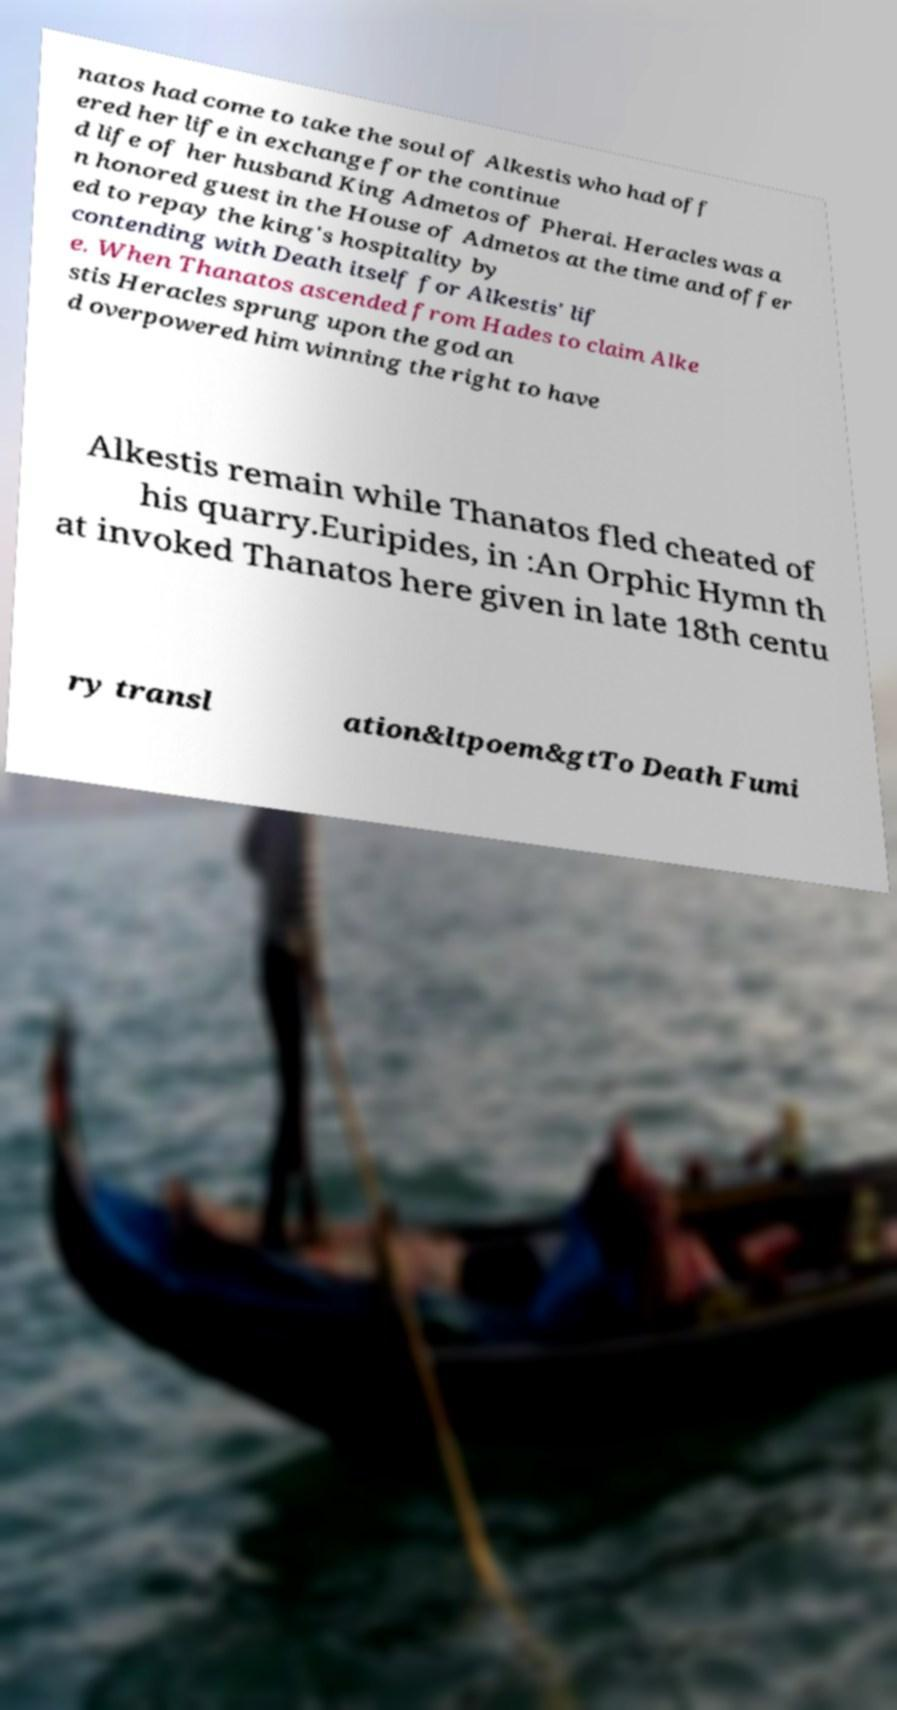There's text embedded in this image that I need extracted. Can you transcribe it verbatim? natos had come to take the soul of Alkestis who had off ered her life in exchange for the continue d life of her husband King Admetos of Pherai. Heracles was a n honored guest in the House of Admetos at the time and offer ed to repay the king's hospitality by contending with Death itself for Alkestis' lif e. When Thanatos ascended from Hades to claim Alke stis Heracles sprung upon the god an d overpowered him winning the right to have Alkestis remain while Thanatos fled cheated of his quarry.Euripides, in :An Orphic Hymn th at invoked Thanatos here given in late 18th centu ry transl ation&ltpoem&gtTo Death Fumi 